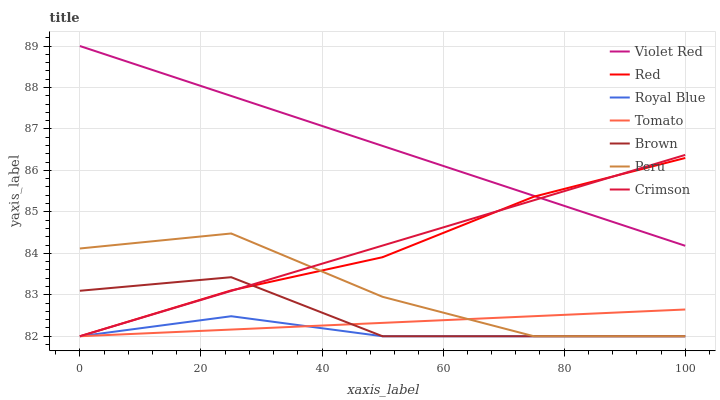Does Royal Blue have the minimum area under the curve?
Answer yes or no. Yes. Does Violet Red have the maximum area under the curve?
Answer yes or no. Yes. Does Brown have the minimum area under the curve?
Answer yes or no. No. Does Brown have the maximum area under the curve?
Answer yes or no. No. Is Crimson the smoothest?
Answer yes or no. Yes. Is Peru the roughest?
Answer yes or no. Yes. Is Brown the smoothest?
Answer yes or no. No. Is Brown the roughest?
Answer yes or no. No. Does Violet Red have the lowest value?
Answer yes or no. No. Does Brown have the highest value?
Answer yes or no. No. Is Peru less than Violet Red?
Answer yes or no. Yes. Is Violet Red greater than Peru?
Answer yes or no. Yes. Does Peru intersect Violet Red?
Answer yes or no. No. 